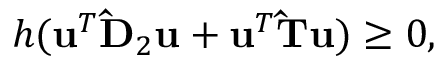<formula> <loc_0><loc_0><loc_500><loc_500>h ( u ^ { T } \hat { D } _ { 2 } u + u ^ { T } \hat { T } u ) \geq 0 ,</formula> 